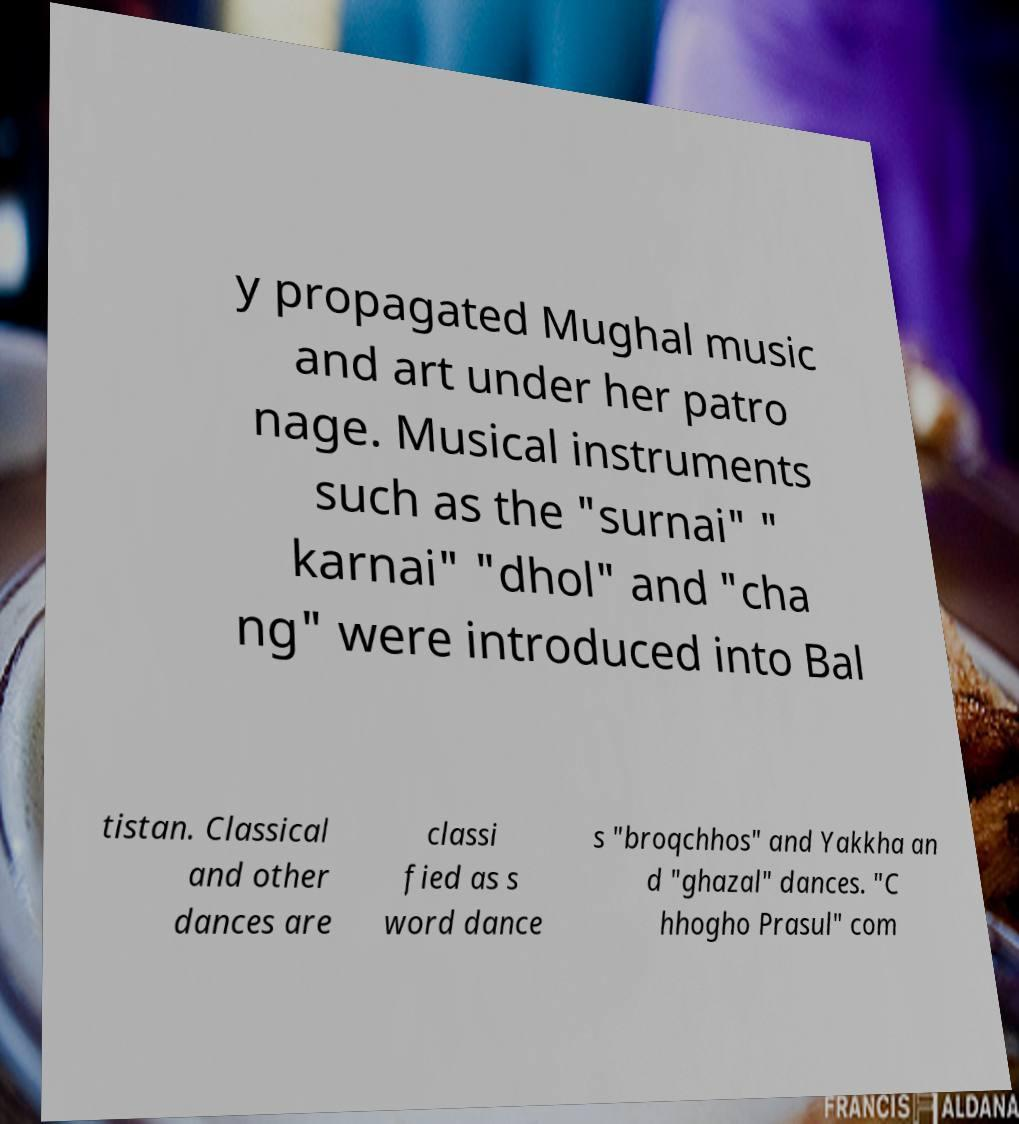Please identify and transcribe the text found in this image. y propagated Mughal music and art under her patro nage. Musical instruments such as the "surnai" " karnai" "dhol" and "cha ng" were introduced into Bal tistan. Classical and other dances are classi fied as s word dance s "broqchhos" and Yakkha an d "ghazal" dances. "C hhogho Prasul" com 